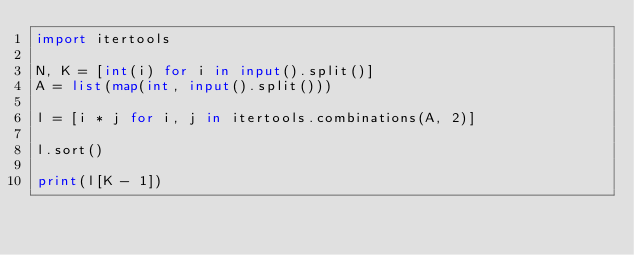<code> <loc_0><loc_0><loc_500><loc_500><_Python_>import itertools

N, K = [int(i) for i in input().split()]
A = list(map(int, input().split()))

l = [i * j for i, j in itertools.combinations(A, 2)]

l.sort()

print(l[K - 1])
</code> 